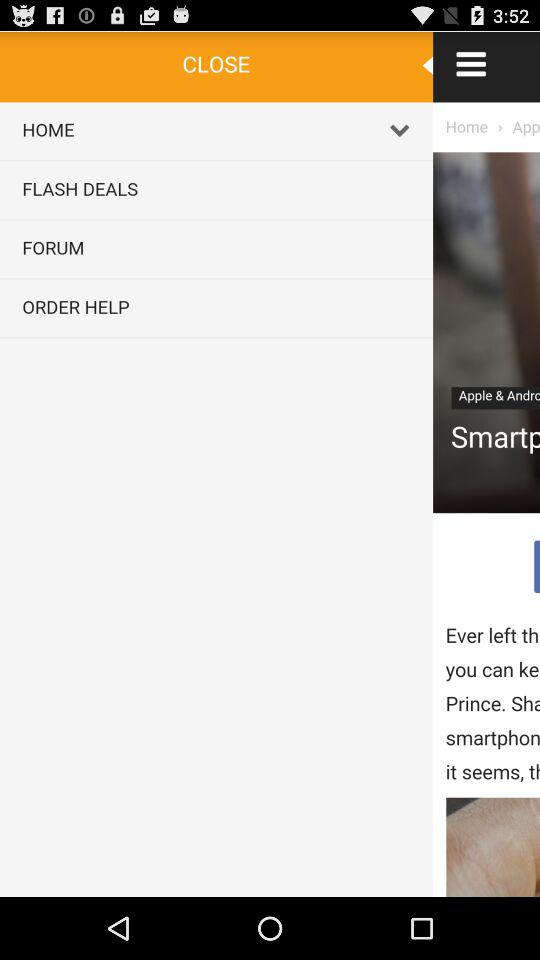How many items are added to the cart? There is 1 item added to the cart. 